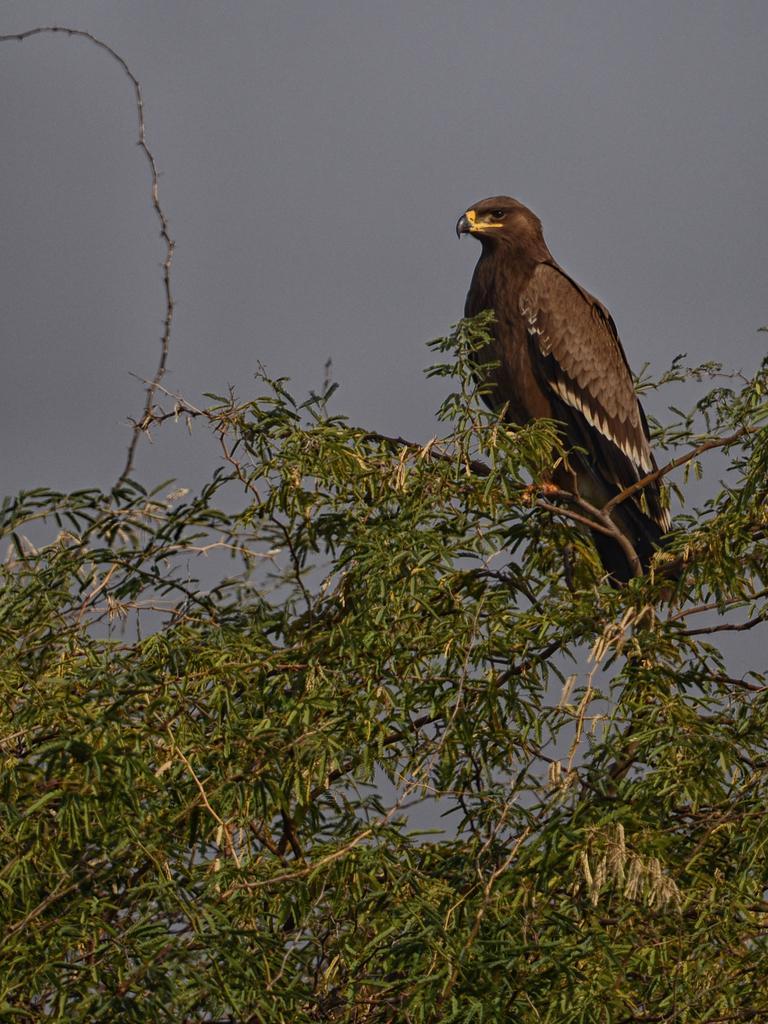How would you summarize this image in a sentence or two? In this image, we can see a bird on the tree. At the top, there is sky. 